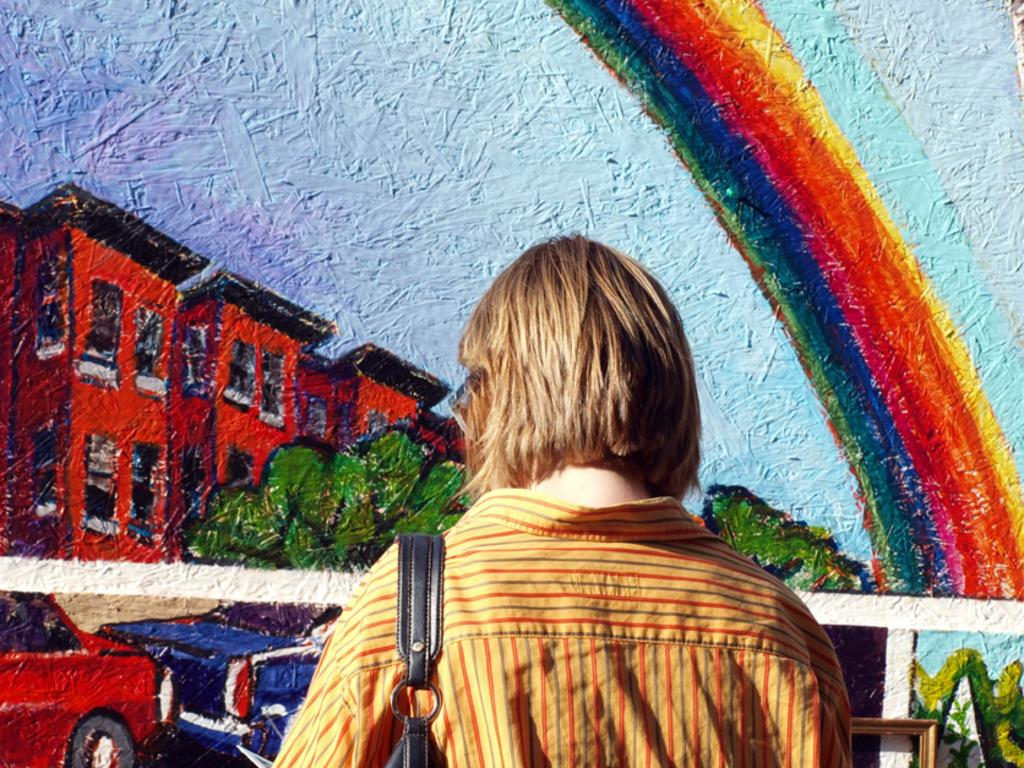What is depicted on the wall in the image? There is a painting on the wall in the image. What is the person in the image doing? The person is watching the painting in the image. What accessory is the person wearing? The person is wearing a handbag. What is the color of the handbag? The handbag is black in color. How does the fan contribute to the distribution of spring in the image? There is no fan or spring present in the image. What type of fan is used for the distribution of spring in the image? There is no fan or spring present in the image, so it is not possible to determine the type of fan used. 